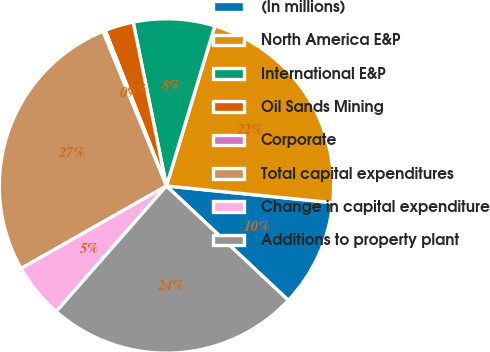<chart> <loc_0><loc_0><loc_500><loc_500><pie_chart><fcel>(In millions)<fcel>North America E&P<fcel>International E&P<fcel>Oil Sands Mining<fcel>Corporate<fcel>Total capital expenditures<fcel>Change in capital expenditure<fcel>Additions to property plant<nl><fcel>10.4%<fcel>21.93%<fcel>7.86%<fcel>2.78%<fcel>0.24%<fcel>27.01%<fcel>5.32%<fcel>24.47%<nl></chart> 